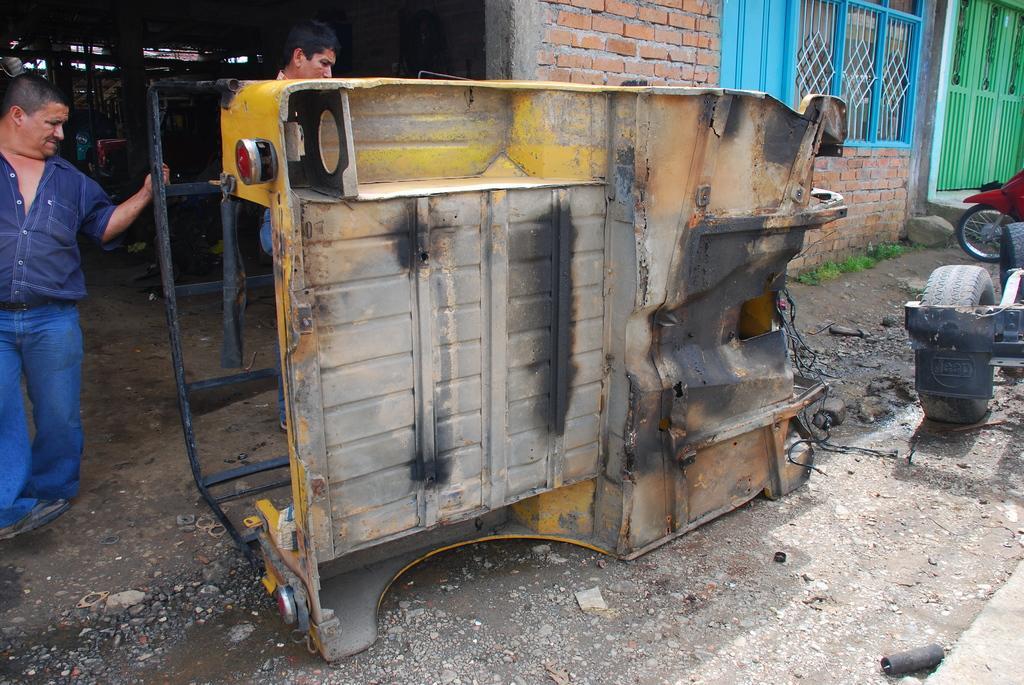In one or two sentences, can you explain what this image depicts? In this image I can see there is a metal vehicle structure and there are two persons standing at the left side. There is a brick wall in the background with few windows and doors, the background at left side is a bit dark. 